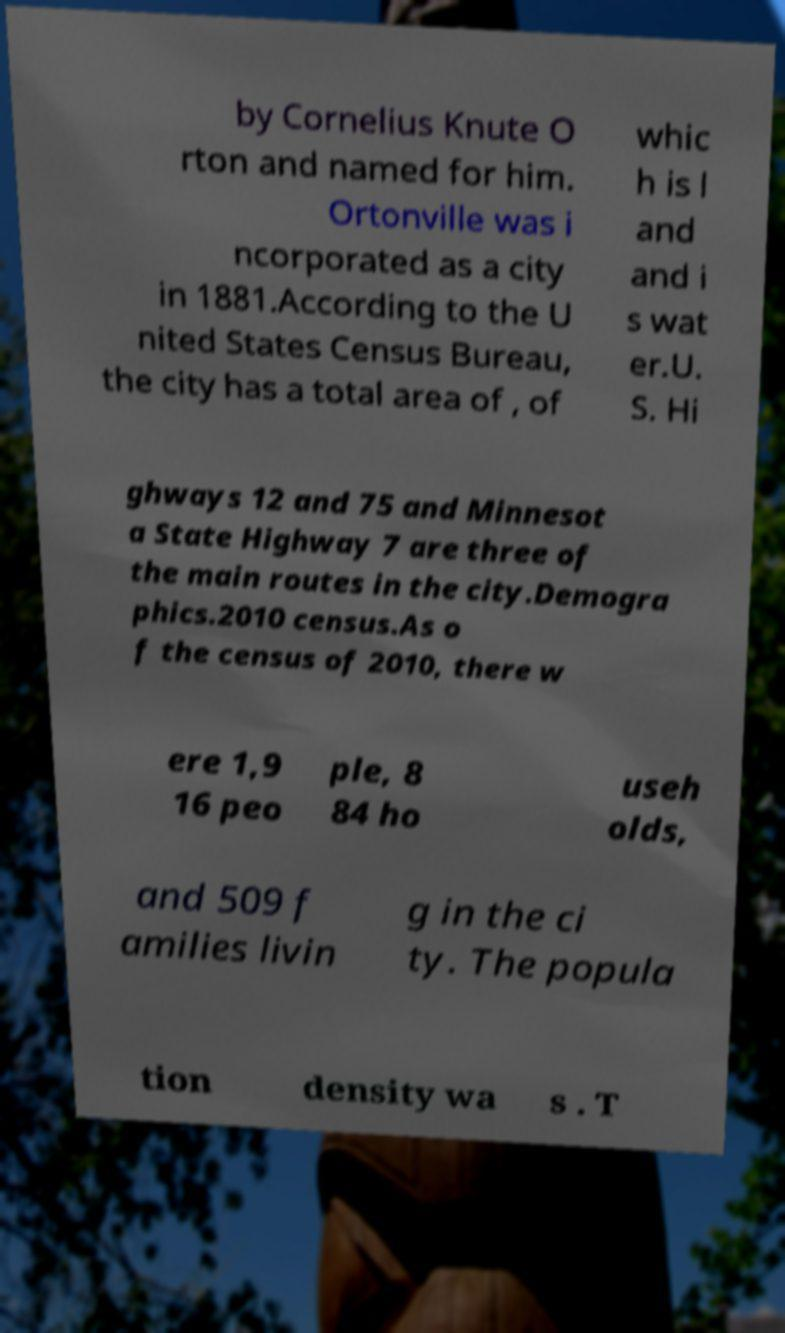Please read and relay the text visible in this image. What does it say? by Cornelius Knute O rton and named for him. Ortonville was i ncorporated as a city in 1881.According to the U nited States Census Bureau, the city has a total area of , of whic h is l and and i s wat er.U. S. Hi ghways 12 and 75 and Minnesot a State Highway 7 are three of the main routes in the city.Demogra phics.2010 census.As o f the census of 2010, there w ere 1,9 16 peo ple, 8 84 ho useh olds, and 509 f amilies livin g in the ci ty. The popula tion density wa s . T 